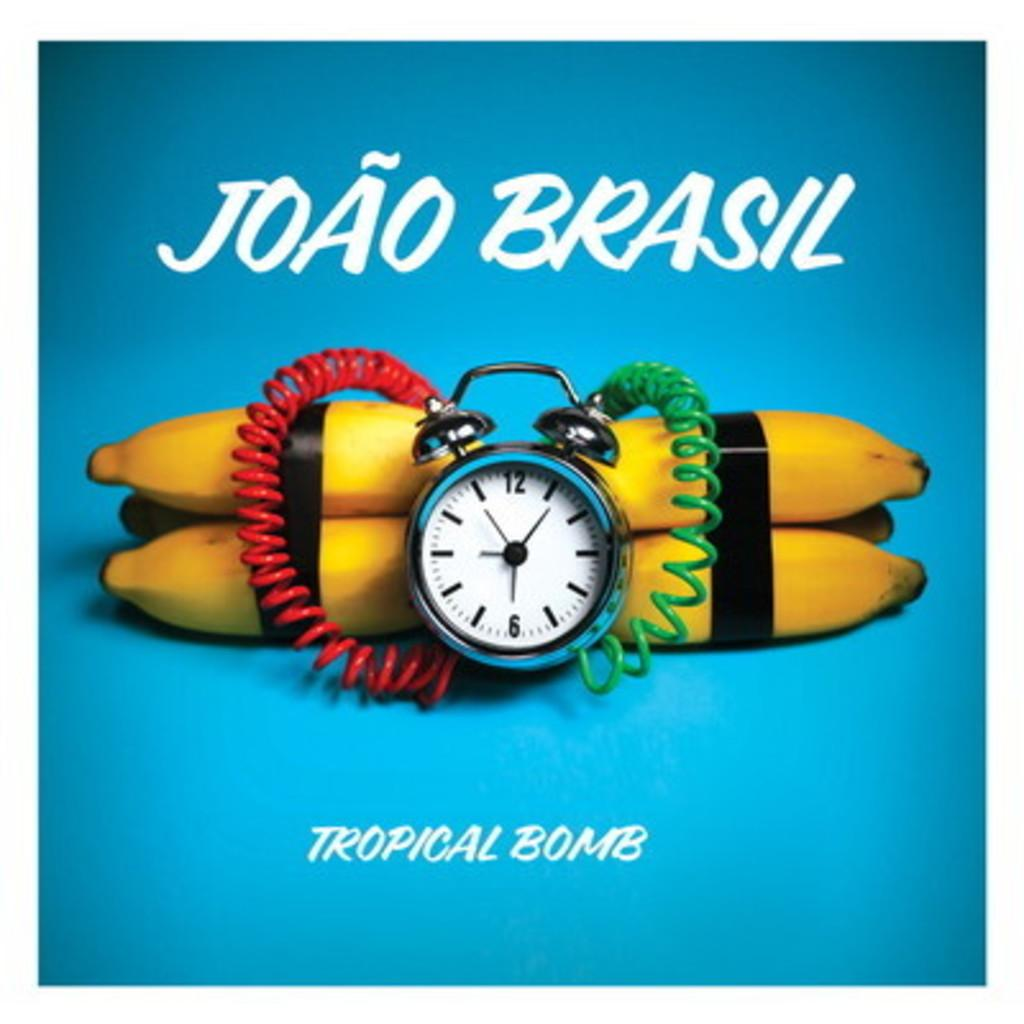Provide a one-sentence caption for the provided image. Joao Brasil has a product called Tropical Bomb. 